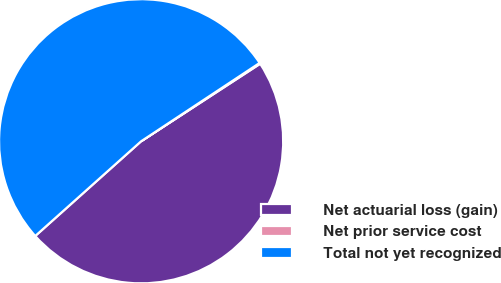Convert chart. <chart><loc_0><loc_0><loc_500><loc_500><pie_chart><fcel>Net actuarial loss (gain)<fcel>Net prior service cost<fcel>Total not yet recognized<nl><fcel>47.57%<fcel>0.11%<fcel>52.32%<nl></chart> 